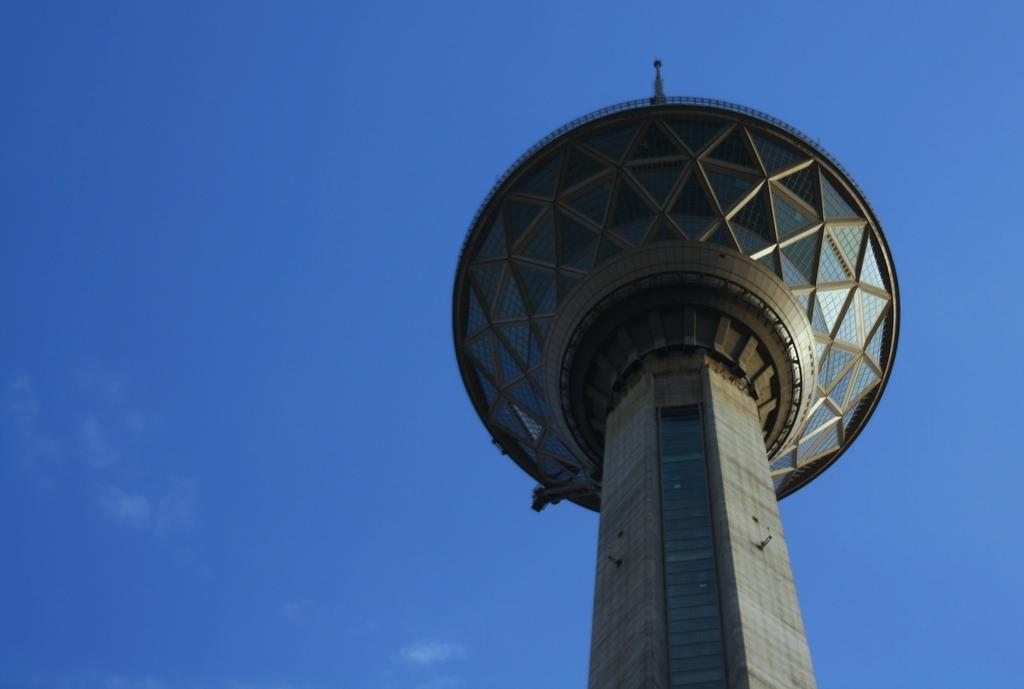What is the main structure visible in the image? There is a tower in the image. What can be seen in the background of the image? The sky is visible in the background of the image. What type of wood is used to build the tower in the image? The image does not provide information about the type of wood used to build the tower. How many crates are stacked on top of the tower in the image? There are no crates present in the image. 